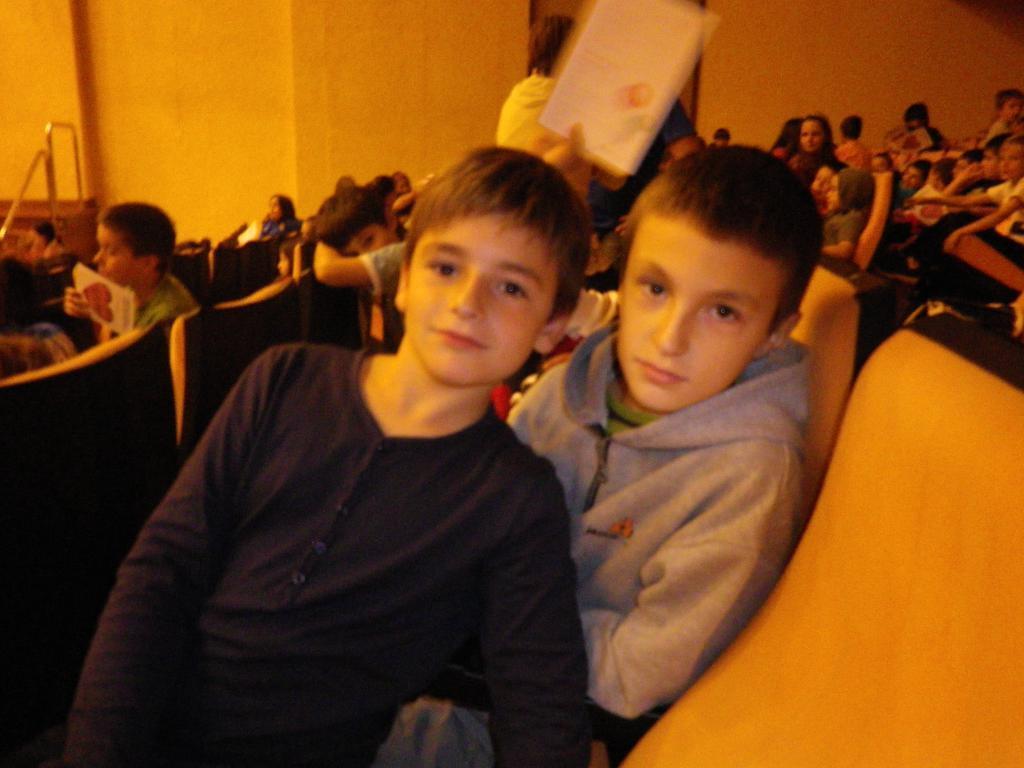How would you summarize this image in a sentence or two? In the foreground, I can see a group of people are sitting on the chairs. In the background, I can see a wall and metal rods. This image is taken, maybe in a hall. 